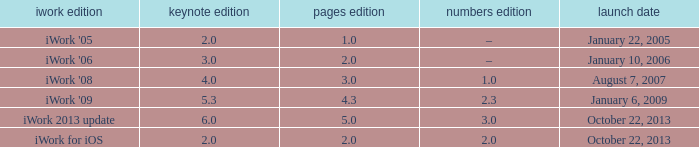What's the latest keynote version of version 2.3 of numbers with pages greater than 4.3? None. 